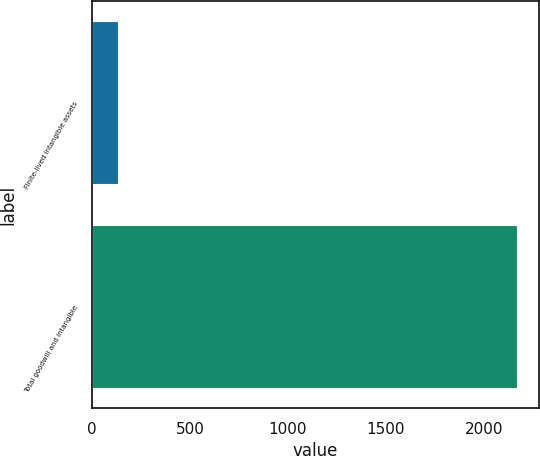<chart> <loc_0><loc_0><loc_500><loc_500><bar_chart><fcel>Finite-lived intangible assets<fcel>Total goodwill and intangible<nl><fcel>131<fcel>2171.5<nl></chart> 